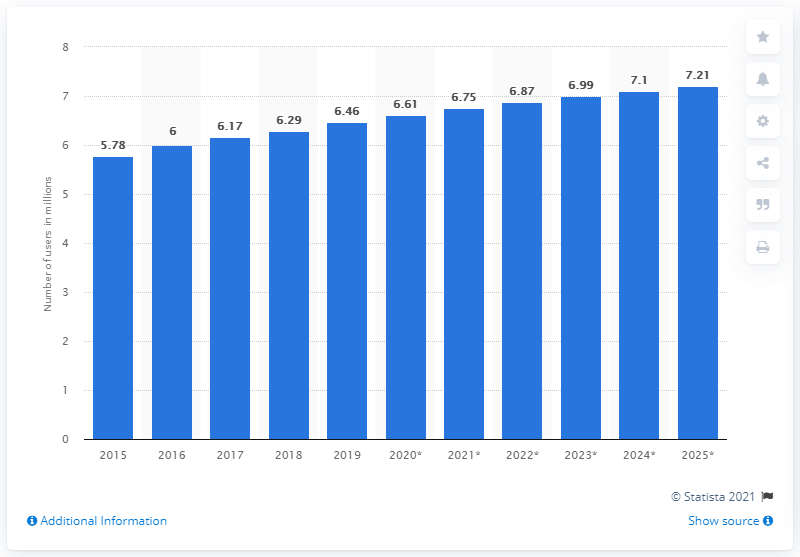Draw attention to some important aspects in this diagram. The projected number of mobile internet users in Hong Kong in 2025 was 7.21. In 2019, it was estimated that 6.46 people in Hong Kong accessed the internet through their mobile phones. 